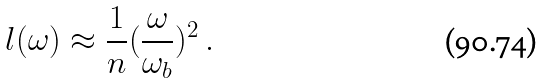Convert formula to latex. <formula><loc_0><loc_0><loc_500><loc_500>l ( \omega ) \approx \frac { 1 } { n } ( \frac { \omega } { \omega _ { b } } ) ^ { 2 } \, .</formula> 